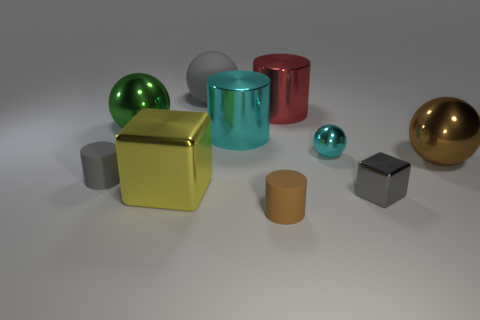The other cylinder that is the same material as the cyan cylinder is what size?
Keep it short and to the point. Large. What number of matte spheres have the same color as the tiny shiny cube?
Provide a short and direct response. 1. Are there fewer big green things that are behind the cyan shiny ball than metal cylinders that are to the right of the large green shiny sphere?
Your answer should be very brief. Yes. There is a gray matte object to the right of the large shiny block; what size is it?
Offer a very short reply. Large. What is the size of the cylinder that is the same color as the tiny metal ball?
Offer a very short reply. Large. Is there a large green ball that has the same material as the large gray sphere?
Keep it short and to the point. No. Are the small gray block and the big yellow block made of the same material?
Offer a terse response. Yes. There is a cube that is the same size as the gray matte sphere; what color is it?
Provide a succinct answer. Yellow. What number of other objects are there of the same shape as the big gray thing?
Your answer should be very brief. 3. Does the gray metal thing have the same size as the brown thing that is to the left of the brown metallic sphere?
Provide a short and direct response. Yes. 